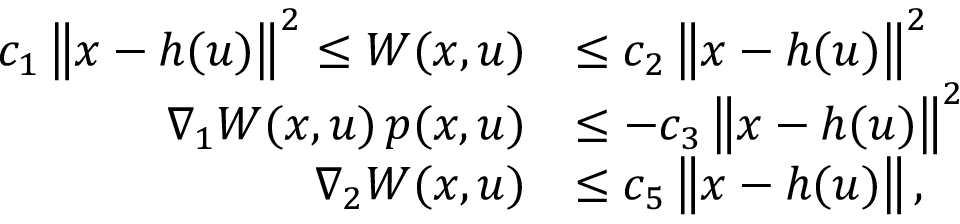Convert formula to latex. <formula><loc_0><loc_0><loc_500><loc_500>\begin{array} { r l } { c _ { 1 } \left \| x - h ( u ) \right \| ^ { 2 } \leq W ( x , u ) } & { \leq c _ { 2 } \left \| x - h ( u ) \right \| ^ { 2 } } \\ { \nabla _ { 1 } W ( x , u ) \, p ( x , u ) } & { \leq - c _ { 3 } \left \| x - h ( u ) \right \| ^ { 2 } } \\ { \nabla _ { 2 } W ( x , u ) } & { \leq c _ { 5 } \left \| x - h ( u ) \right \| , } \end{array}</formula> 